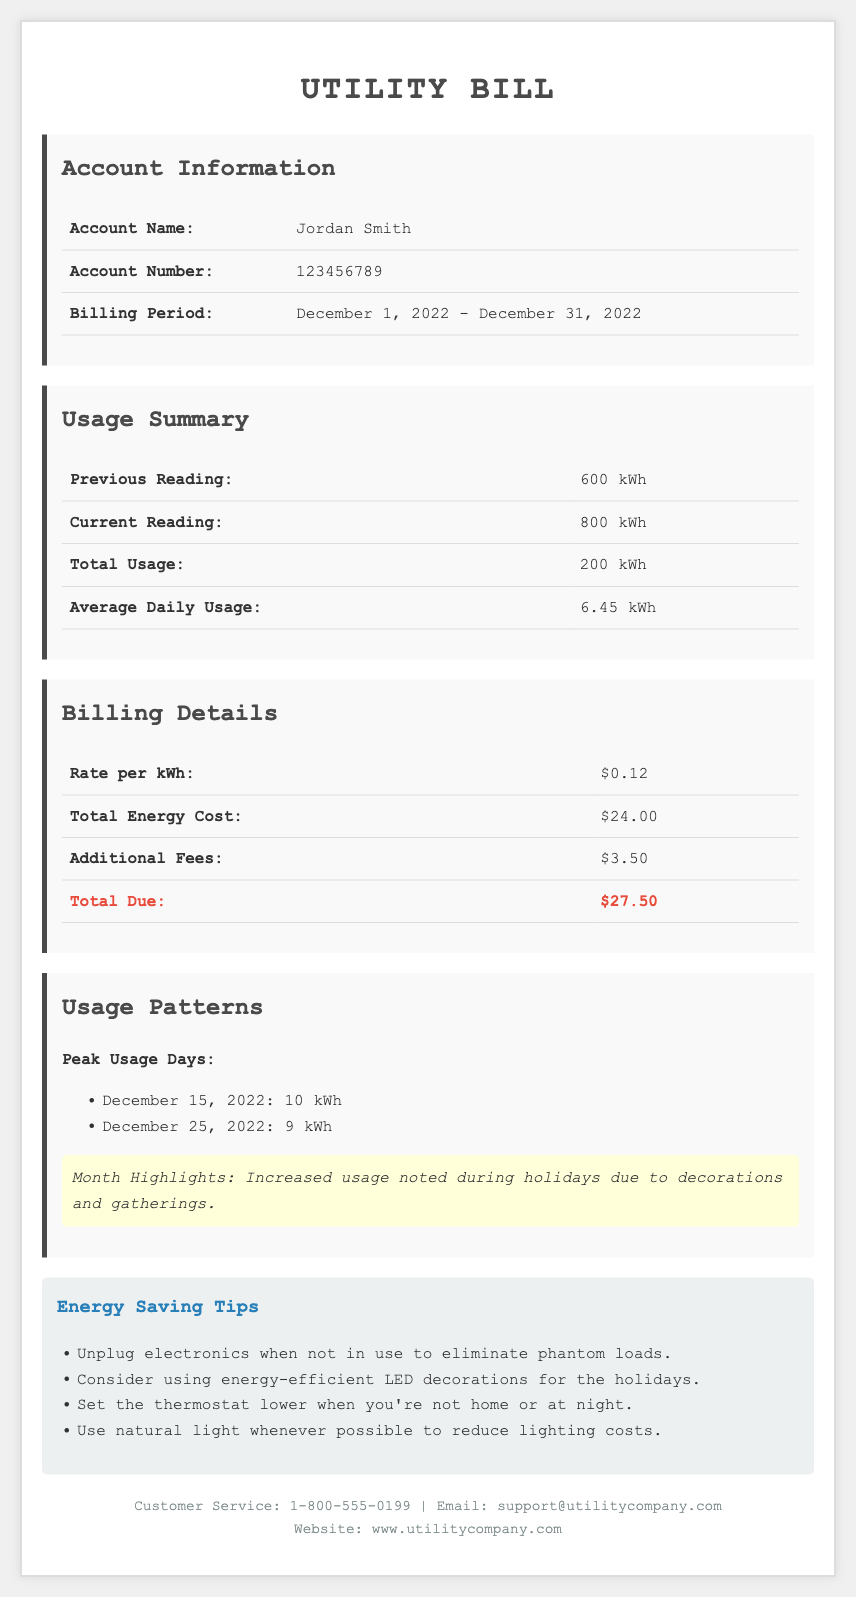what is the account name? The account name is provided in the account information section of the document.
Answer: Jordan Smith what is the total usage for December 2022? The total usage is stated in the usage summary section of the document.
Answer: 200 kWh what is the rate per kWh? The rate per kWh is indicated in the billing details section of the document.
Answer: $0.12 what were the peak usage days? The peak usage days are listed in the usage patterns section of the document.
Answer: December 15, 2022; December 25, 2022 what is the total due amount? The total due amount is calculated from the billing details section in the document.
Answer: $27.50 how many kWh was consumed on December 15, 2022? The consumption for December 15, 2022 is a part of the peak usage days listed.
Answer: 10 kWh what additional fees are applied? The additional fees can be found in the billing details section.
Answer: $3.50 which month had increased energy usage? The month is mentioned in the usage patterns section highlighting increased usage.
Answer: December 